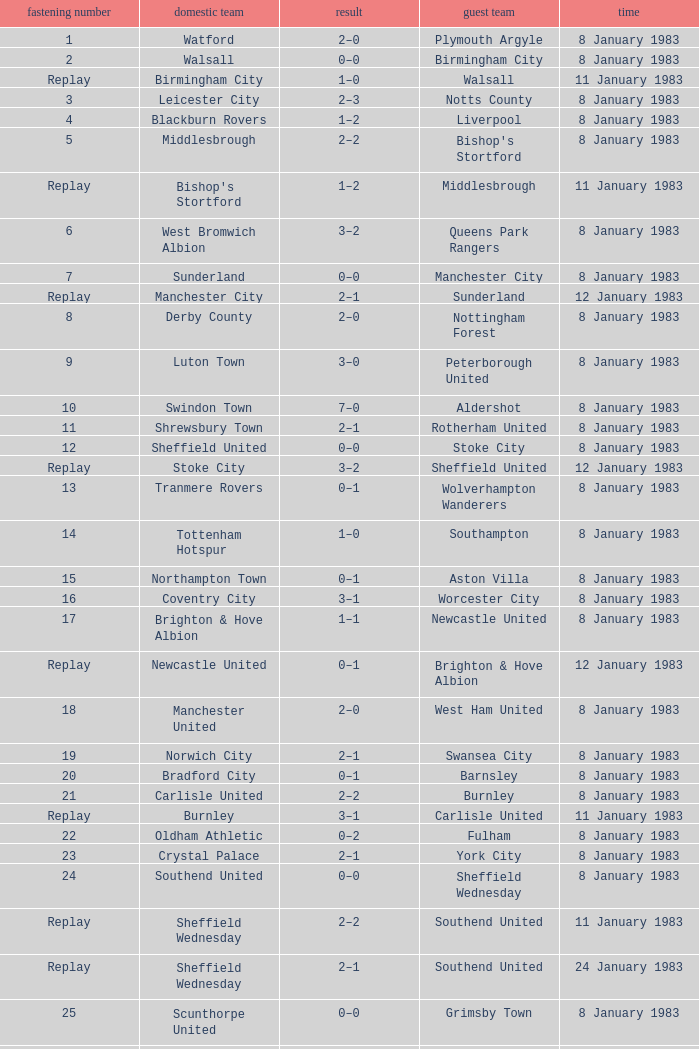On what date was Tie #26 played? 8 January 1983. 